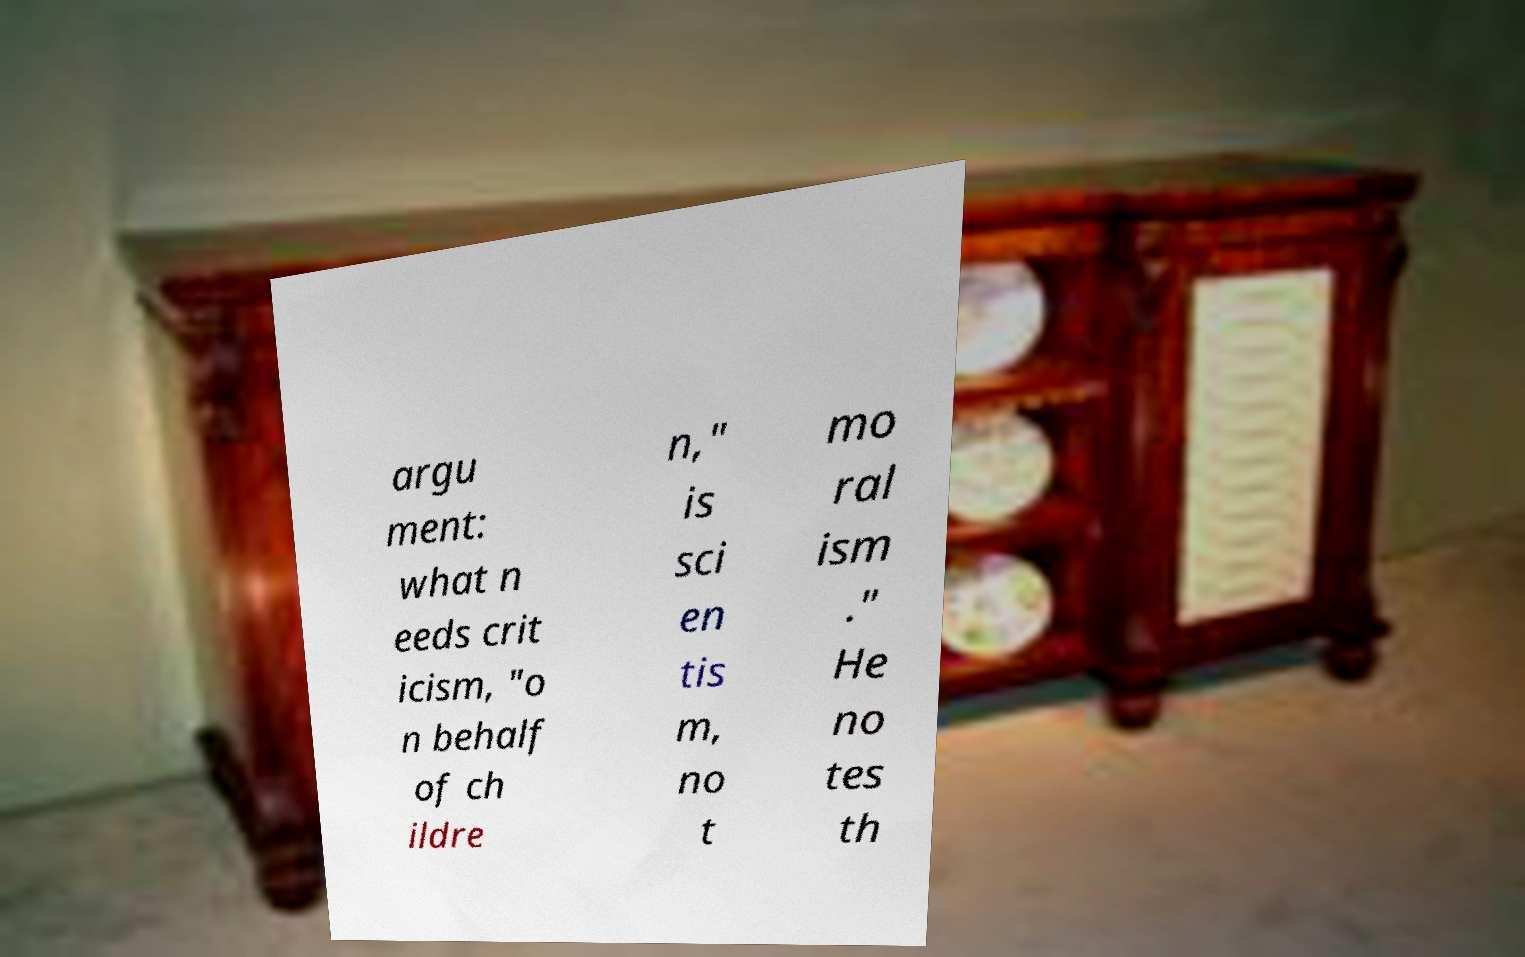Can you read and provide the text displayed in the image?This photo seems to have some interesting text. Can you extract and type it out for me? argu ment: what n eeds crit icism, "o n behalf of ch ildre n," is sci en tis m, no t mo ral ism ." He no tes th 